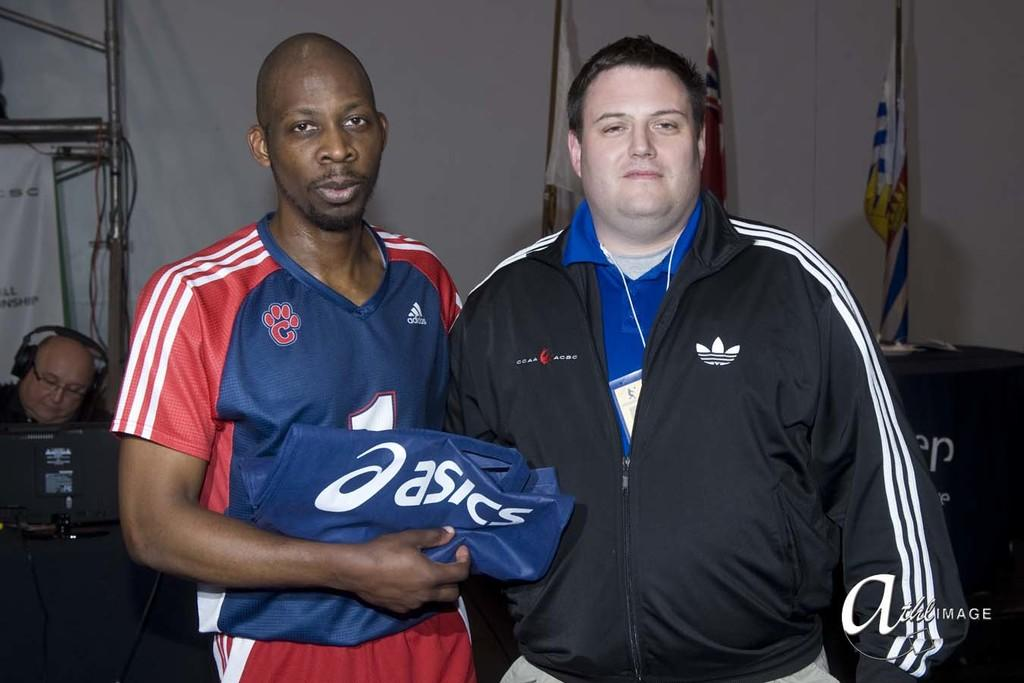<image>
Present a compact description of the photo's key features. Man holding a Basics shirt standing next to another man. 